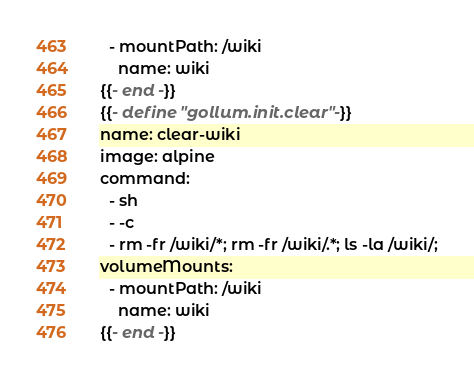<code> <loc_0><loc_0><loc_500><loc_500><_YAML_>  - mountPath: /wiki
    name: wiki
{{- end -}}
{{- define "gollum.init.clear" -}}
name: clear-wiki
image: alpine
command:
  - sh
  - -c
  - rm -fr /wiki/*; rm -fr /wiki/.*; ls -la /wiki/;
volumeMounts:
  - mountPath: /wiki
    name: wiki
{{- end -}}
</code> 